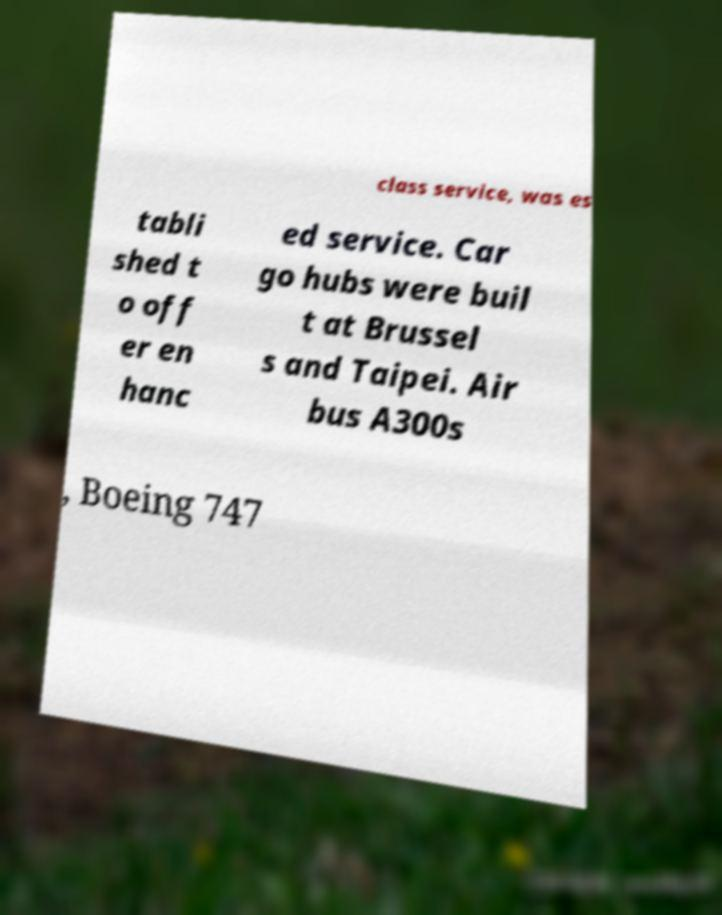Could you assist in decoding the text presented in this image and type it out clearly? class service, was es tabli shed t o off er en hanc ed service. Car go hubs were buil t at Brussel s and Taipei. Air bus A300s , Boeing 747 